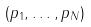<formula> <loc_0><loc_0><loc_500><loc_500>( p _ { 1 } , \dots , p _ { N } )</formula> 